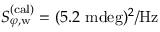Convert formula to latex. <formula><loc_0><loc_0><loc_500><loc_500>S _ { \varphi , w } ^ { ( c a l ) } = ( 5 . 2 m d e g ) ^ { 2 } / H z</formula> 